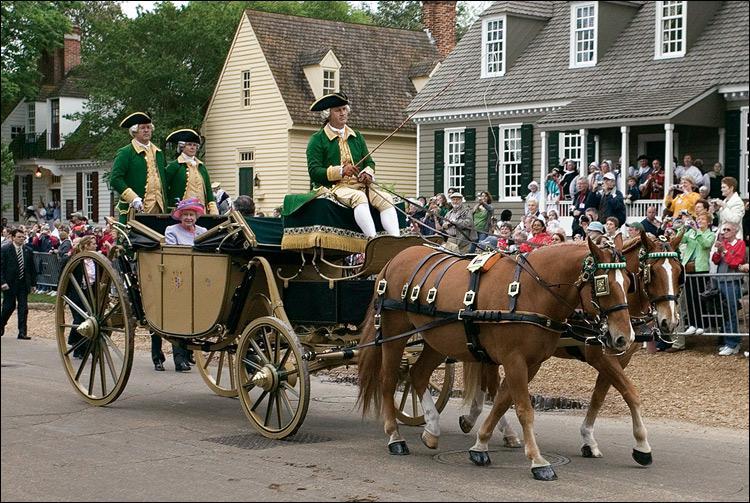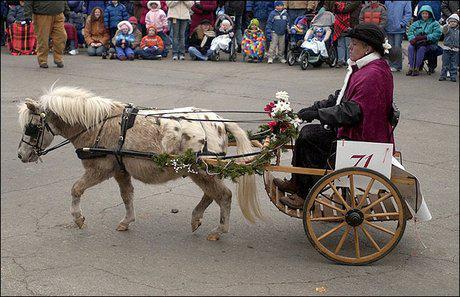The first image is the image on the left, the second image is the image on the right. Examine the images to the left and right. Is the description "One image features a four-wheeled cart pulled by just one horse." accurate? Answer yes or no. No. 